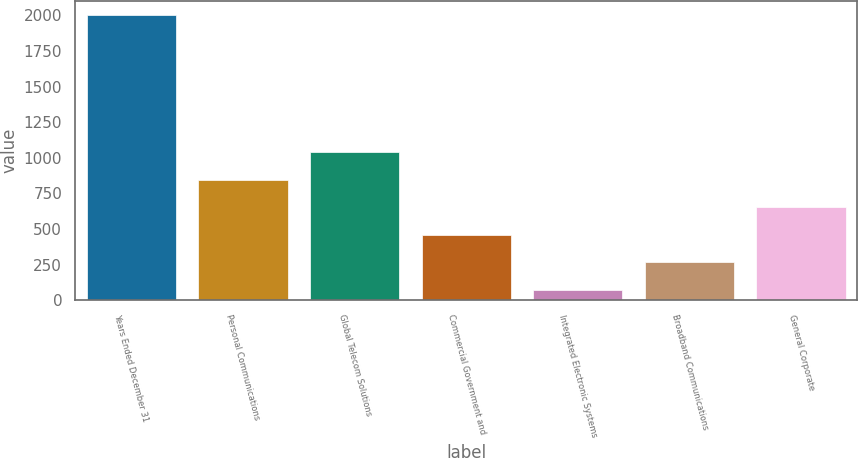Convert chart to OTSL. <chart><loc_0><loc_0><loc_500><loc_500><bar_chart><fcel>Years Ended December 31<fcel>Personal Communications<fcel>Global Telecom Solutions<fcel>Commercial Government and<fcel>Integrated Electronic Systems<fcel>Broadband Communications<fcel>General Corporate<nl><fcel>2002<fcel>845.8<fcel>1038.5<fcel>460.4<fcel>75<fcel>267.7<fcel>653.1<nl></chart> 